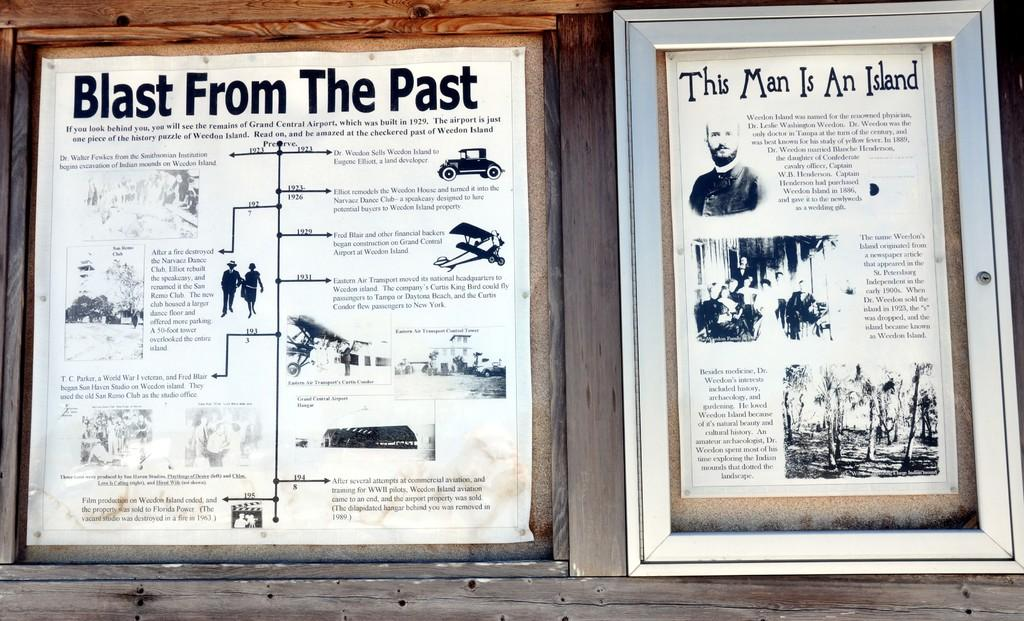<image>
Present a compact description of the photo's key features. a framed paper that is titled 'this man is an island' 